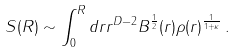<formula> <loc_0><loc_0><loc_500><loc_500>S ( R ) \sim \int _ { 0 } ^ { R } d r r ^ { D - 2 } B ^ { \frac { 1 } { 2 } } ( r ) \rho ( r ) ^ { \frac { 1 } { 1 + \kappa } } \, .</formula> 